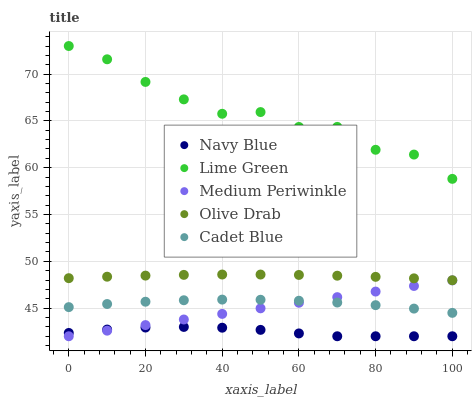Does Navy Blue have the minimum area under the curve?
Answer yes or no. Yes. Does Lime Green have the maximum area under the curve?
Answer yes or no. Yes. Does Cadet Blue have the minimum area under the curve?
Answer yes or no. No. Does Cadet Blue have the maximum area under the curve?
Answer yes or no. No. Is Medium Periwinkle the smoothest?
Answer yes or no. Yes. Is Lime Green the roughest?
Answer yes or no. Yes. Is Cadet Blue the smoothest?
Answer yes or no. No. Is Cadet Blue the roughest?
Answer yes or no. No. Does Navy Blue have the lowest value?
Answer yes or no. Yes. Does Cadet Blue have the lowest value?
Answer yes or no. No. Does Lime Green have the highest value?
Answer yes or no. Yes. Does Cadet Blue have the highest value?
Answer yes or no. No. Is Cadet Blue less than Lime Green?
Answer yes or no. Yes. Is Lime Green greater than Cadet Blue?
Answer yes or no. Yes. Does Medium Periwinkle intersect Cadet Blue?
Answer yes or no. Yes. Is Medium Periwinkle less than Cadet Blue?
Answer yes or no. No. Is Medium Periwinkle greater than Cadet Blue?
Answer yes or no. No. Does Cadet Blue intersect Lime Green?
Answer yes or no. No. 